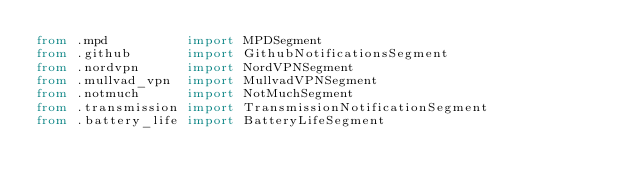Convert code to text. <code><loc_0><loc_0><loc_500><loc_500><_Python_>from .mpd          import MPDSegment
from .github       import GithubNotificationsSegment
from .nordvpn      import NordVPNSegment
from .mullvad_vpn  import MullvadVPNSegment
from .notmuch      import NotMuchSegment
from .transmission import TransmissionNotificationSegment
from .battery_life import BatteryLifeSegment
</code> 